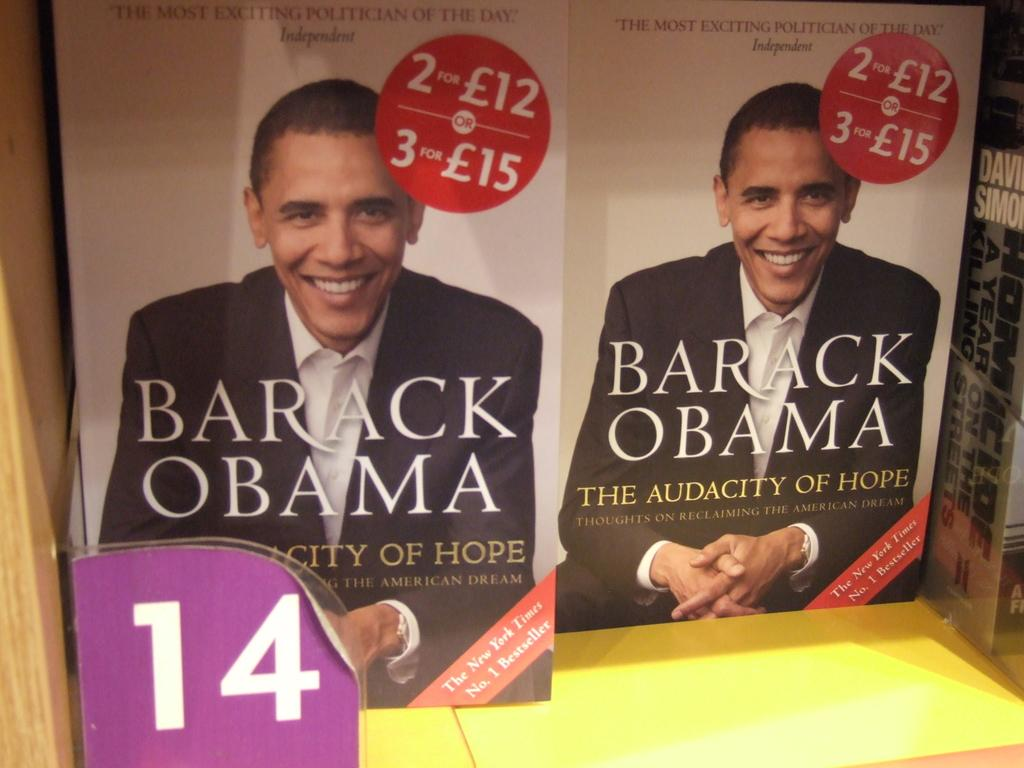<image>
Summarize the visual content of the image. Two copies of a book titled, Barack Obama - The Audacity of Hope being advertised. 